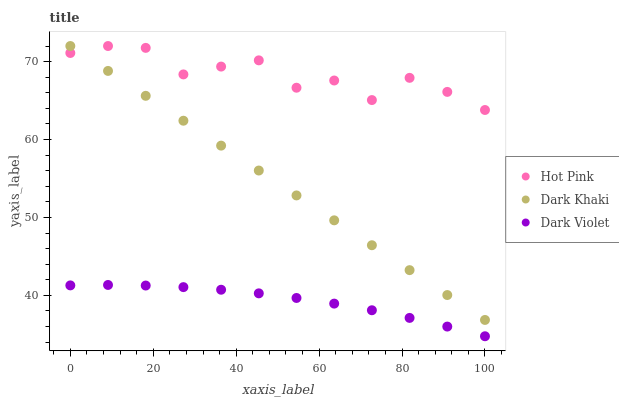Does Dark Violet have the minimum area under the curve?
Answer yes or no. Yes. Does Hot Pink have the maximum area under the curve?
Answer yes or no. Yes. Does Hot Pink have the minimum area under the curve?
Answer yes or no. No. Does Dark Violet have the maximum area under the curve?
Answer yes or no. No. Is Dark Khaki the smoothest?
Answer yes or no. Yes. Is Hot Pink the roughest?
Answer yes or no. Yes. Is Dark Violet the smoothest?
Answer yes or no. No. Is Dark Violet the roughest?
Answer yes or no. No. Does Dark Violet have the lowest value?
Answer yes or no. Yes. Does Hot Pink have the lowest value?
Answer yes or no. No. Does Hot Pink have the highest value?
Answer yes or no. Yes. Does Dark Violet have the highest value?
Answer yes or no. No. Is Dark Violet less than Dark Khaki?
Answer yes or no. Yes. Is Dark Khaki greater than Dark Violet?
Answer yes or no. Yes. Does Hot Pink intersect Dark Khaki?
Answer yes or no. Yes. Is Hot Pink less than Dark Khaki?
Answer yes or no. No. Is Hot Pink greater than Dark Khaki?
Answer yes or no. No. Does Dark Violet intersect Dark Khaki?
Answer yes or no. No. 